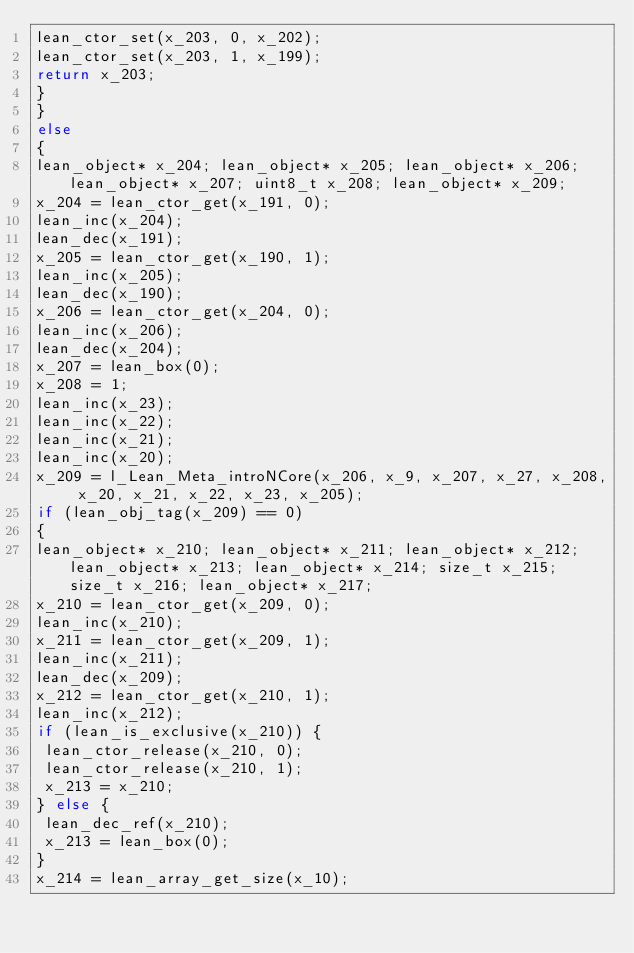<code> <loc_0><loc_0><loc_500><loc_500><_C_>lean_ctor_set(x_203, 0, x_202);
lean_ctor_set(x_203, 1, x_199);
return x_203;
}
}
else
{
lean_object* x_204; lean_object* x_205; lean_object* x_206; lean_object* x_207; uint8_t x_208; lean_object* x_209; 
x_204 = lean_ctor_get(x_191, 0);
lean_inc(x_204);
lean_dec(x_191);
x_205 = lean_ctor_get(x_190, 1);
lean_inc(x_205);
lean_dec(x_190);
x_206 = lean_ctor_get(x_204, 0);
lean_inc(x_206);
lean_dec(x_204);
x_207 = lean_box(0);
x_208 = 1;
lean_inc(x_23);
lean_inc(x_22);
lean_inc(x_21);
lean_inc(x_20);
x_209 = l_Lean_Meta_introNCore(x_206, x_9, x_207, x_27, x_208, x_20, x_21, x_22, x_23, x_205);
if (lean_obj_tag(x_209) == 0)
{
lean_object* x_210; lean_object* x_211; lean_object* x_212; lean_object* x_213; lean_object* x_214; size_t x_215; size_t x_216; lean_object* x_217; 
x_210 = lean_ctor_get(x_209, 0);
lean_inc(x_210);
x_211 = lean_ctor_get(x_209, 1);
lean_inc(x_211);
lean_dec(x_209);
x_212 = lean_ctor_get(x_210, 1);
lean_inc(x_212);
if (lean_is_exclusive(x_210)) {
 lean_ctor_release(x_210, 0);
 lean_ctor_release(x_210, 1);
 x_213 = x_210;
} else {
 lean_dec_ref(x_210);
 x_213 = lean_box(0);
}
x_214 = lean_array_get_size(x_10);</code> 